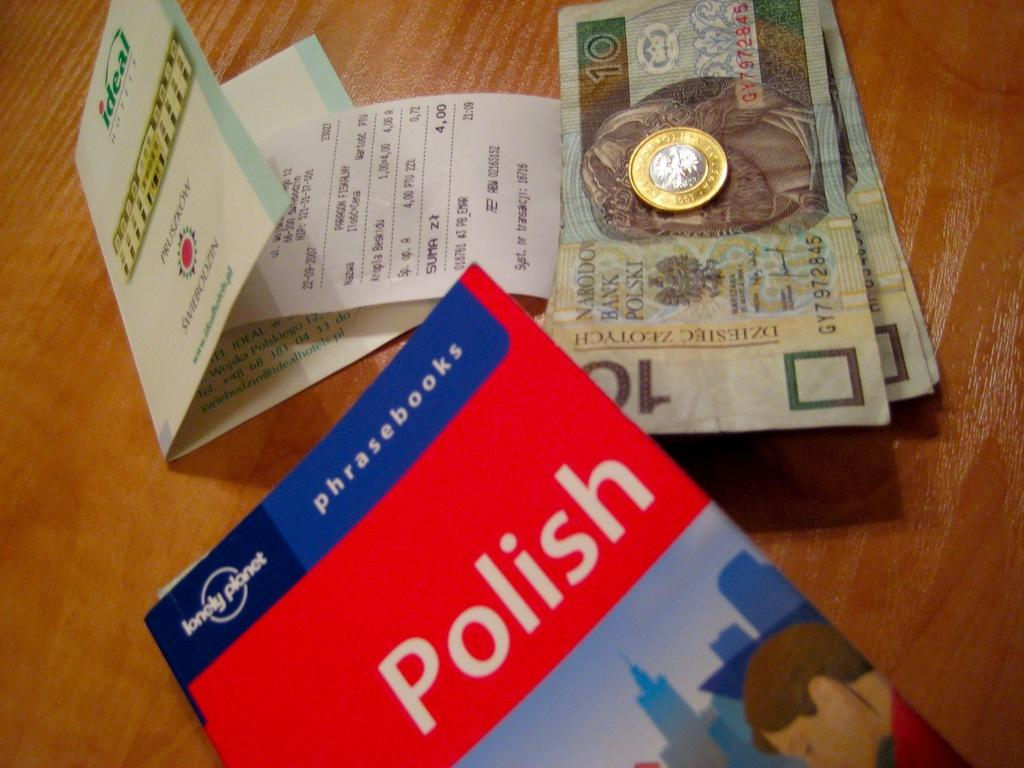Provide a one-sentence caption for the provided image. A book of Polish phrasebooks is on a table. 